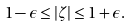<formula> <loc_0><loc_0><loc_500><loc_500>1 - \epsilon \leq \left | \zeta \right | \leq 1 + \epsilon .</formula> 